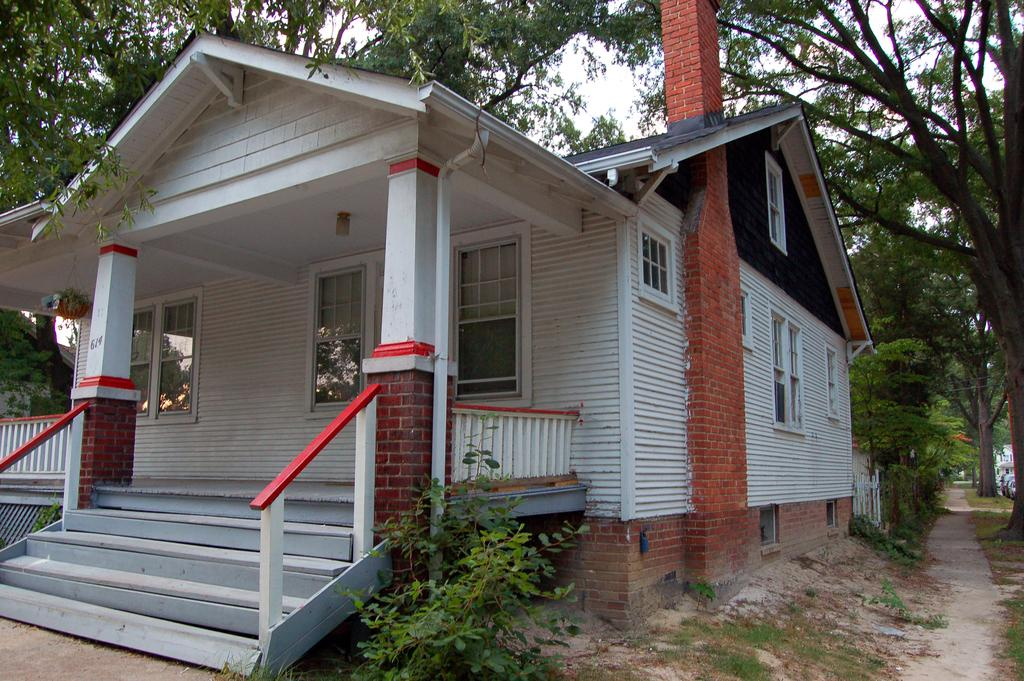What type of structure is visible in the image? There is a home in the image. Where is the home located in relation to the image? The home is in the back of the image. What type of natural elements can be seen in the image? There are trees and plants in the image. How many servants are visible in the image? There are no servants present in the image. What type of sink can be seen in the image? There is no sink present in the image. 